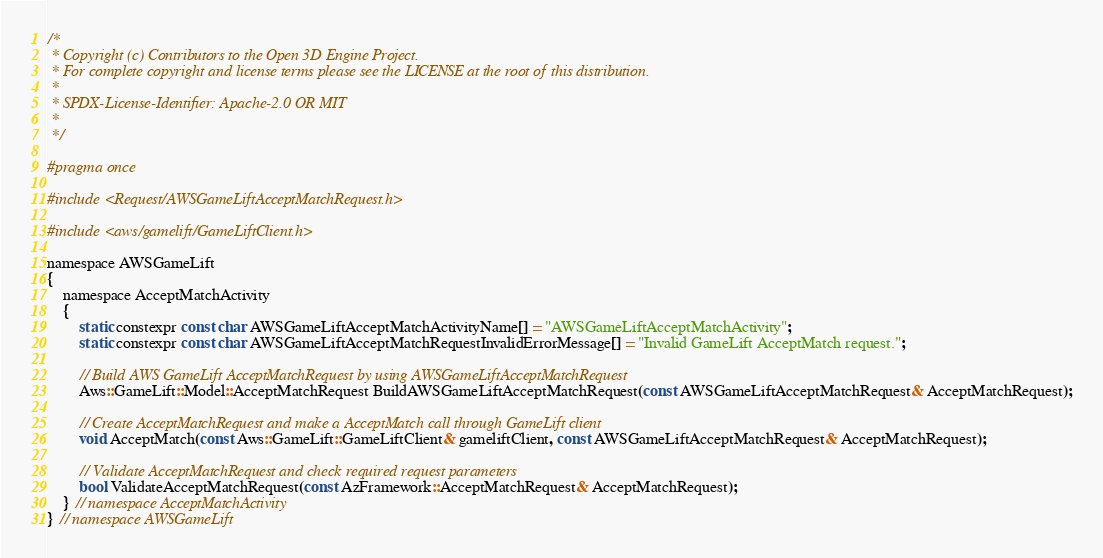<code> <loc_0><loc_0><loc_500><loc_500><_C_>/*
 * Copyright (c) Contributors to the Open 3D Engine Project.
 * For complete copyright and license terms please see the LICENSE at the root of this distribution.
 *
 * SPDX-License-Identifier: Apache-2.0 OR MIT
 *
 */

#pragma once

#include <Request/AWSGameLiftAcceptMatchRequest.h>

#include <aws/gamelift/GameLiftClient.h>

namespace AWSGameLift
{
    namespace AcceptMatchActivity
    {
        static constexpr const char AWSGameLiftAcceptMatchActivityName[] = "AWSGameLiftAcceptMatchActivity";
        static constexpr const char AWSGameLiftAcceptMatchRequestInvalidErrorMessage[] = "Invalid GameLift AcceptMatch request.";

        // Build AWS GameLift AcceptMatchRequest by using AWSGameLiftAcceptMatchRequest
        Aws::GameLift::Model::AcceptMatchRequest BuildAWSGameLiftAcceptMatchRequest(const AWSGameLiftAcceptMatchRequest& AcceptMatchRequest);

        // Create AcceptMatchRequest and make a AcceptMatch call through GameLift client
        void AcceptMatch(const Aws::GameLift::GameLiftClient& gameliftClient, const AWSGameLiftAcceptMatchRequest& AcceptMatchRequest);

        // Validate AcceptMatchRequest and check required request parameters
        bool ValidateAcceptMatchRequest(const AzFramework::AcceptMatchRequest& AcceptMatchRequest);
    } // namespace AcceptMatchActivity
} // namespace AWSGameLift
</code> 